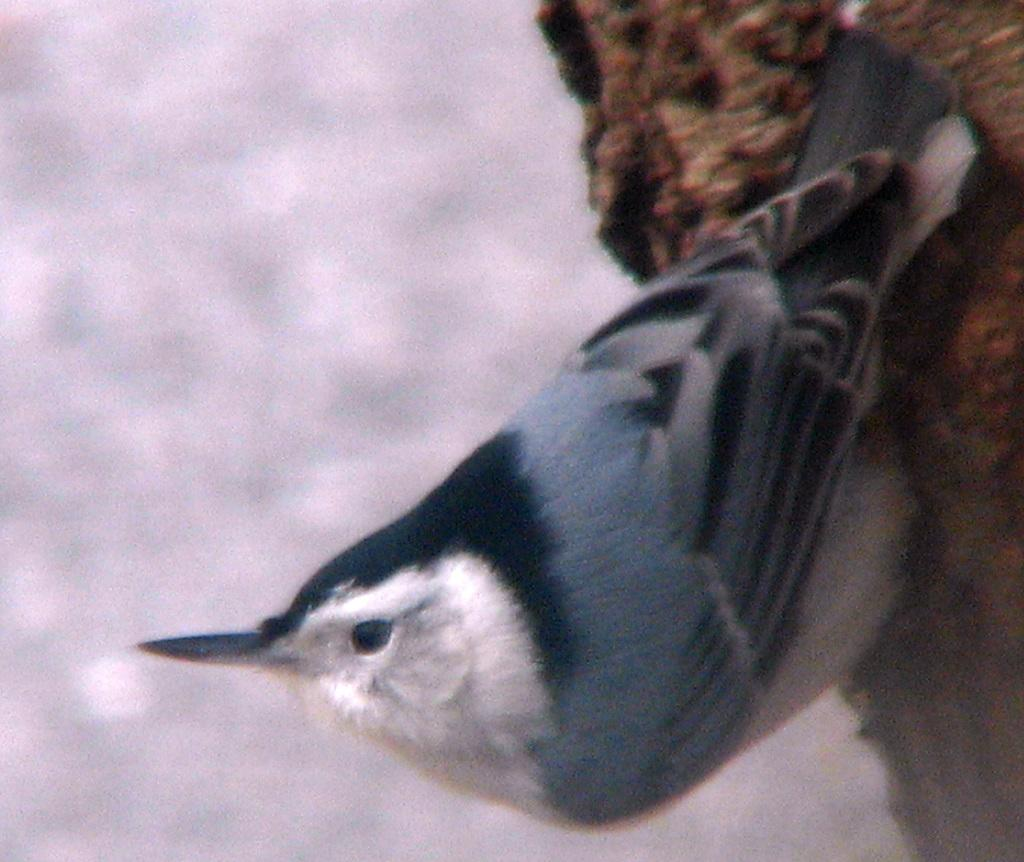What type of animal can be seen in the image? There is a bird in the image. Where is the bird located? The bird is on a tree trunk. Can you describe the position of the bird in the image? The bird is in the center of the image. What type of feast is being prepared in the oven in the image? There is no oven or feast present in the image; it features a bird on a tree trunk. Can you describe the woman in the image? There is no woman present in the image; it features a bird on a tree trunk. 